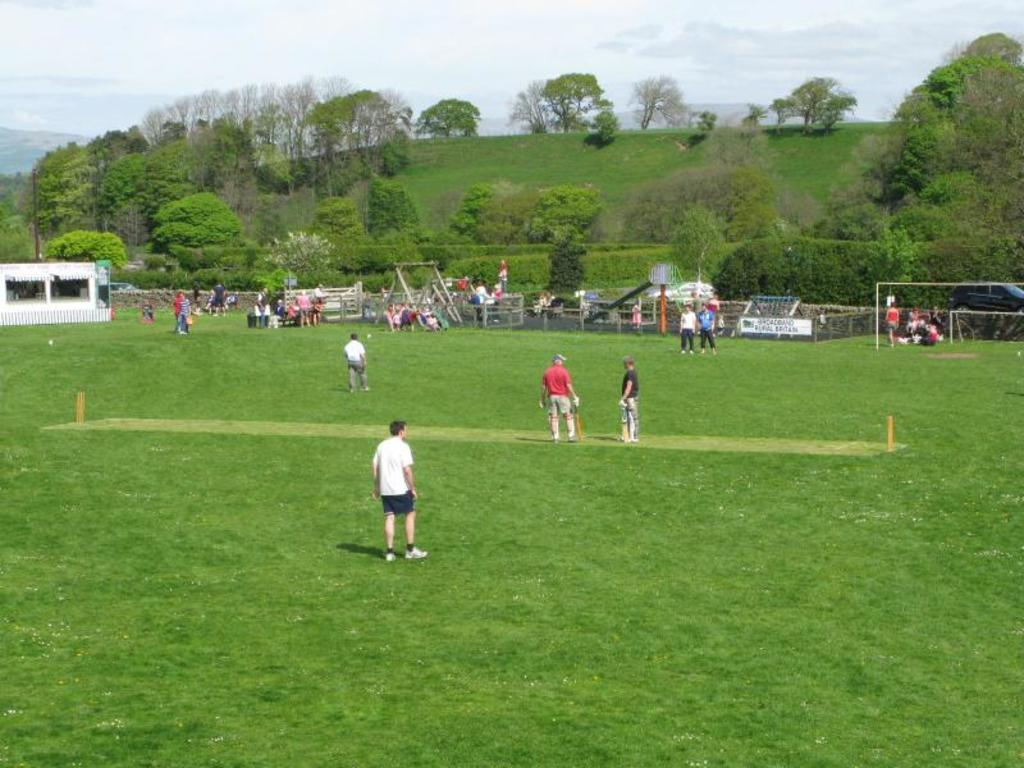What can be seen in the image? There are people standing in the image. What structures are visible in the background of the image? There is a shed, a tent, a swing, and a slide in the background of the image. What other recreational items can be seen in the background of the image? There are other games visible in the background of the image. What type of natural environment is present in the background of the image? There are many trees in the background of the image. What type of note is being passed between the people in the image? There is no note being passed between the people in the image; they are simply standing. 